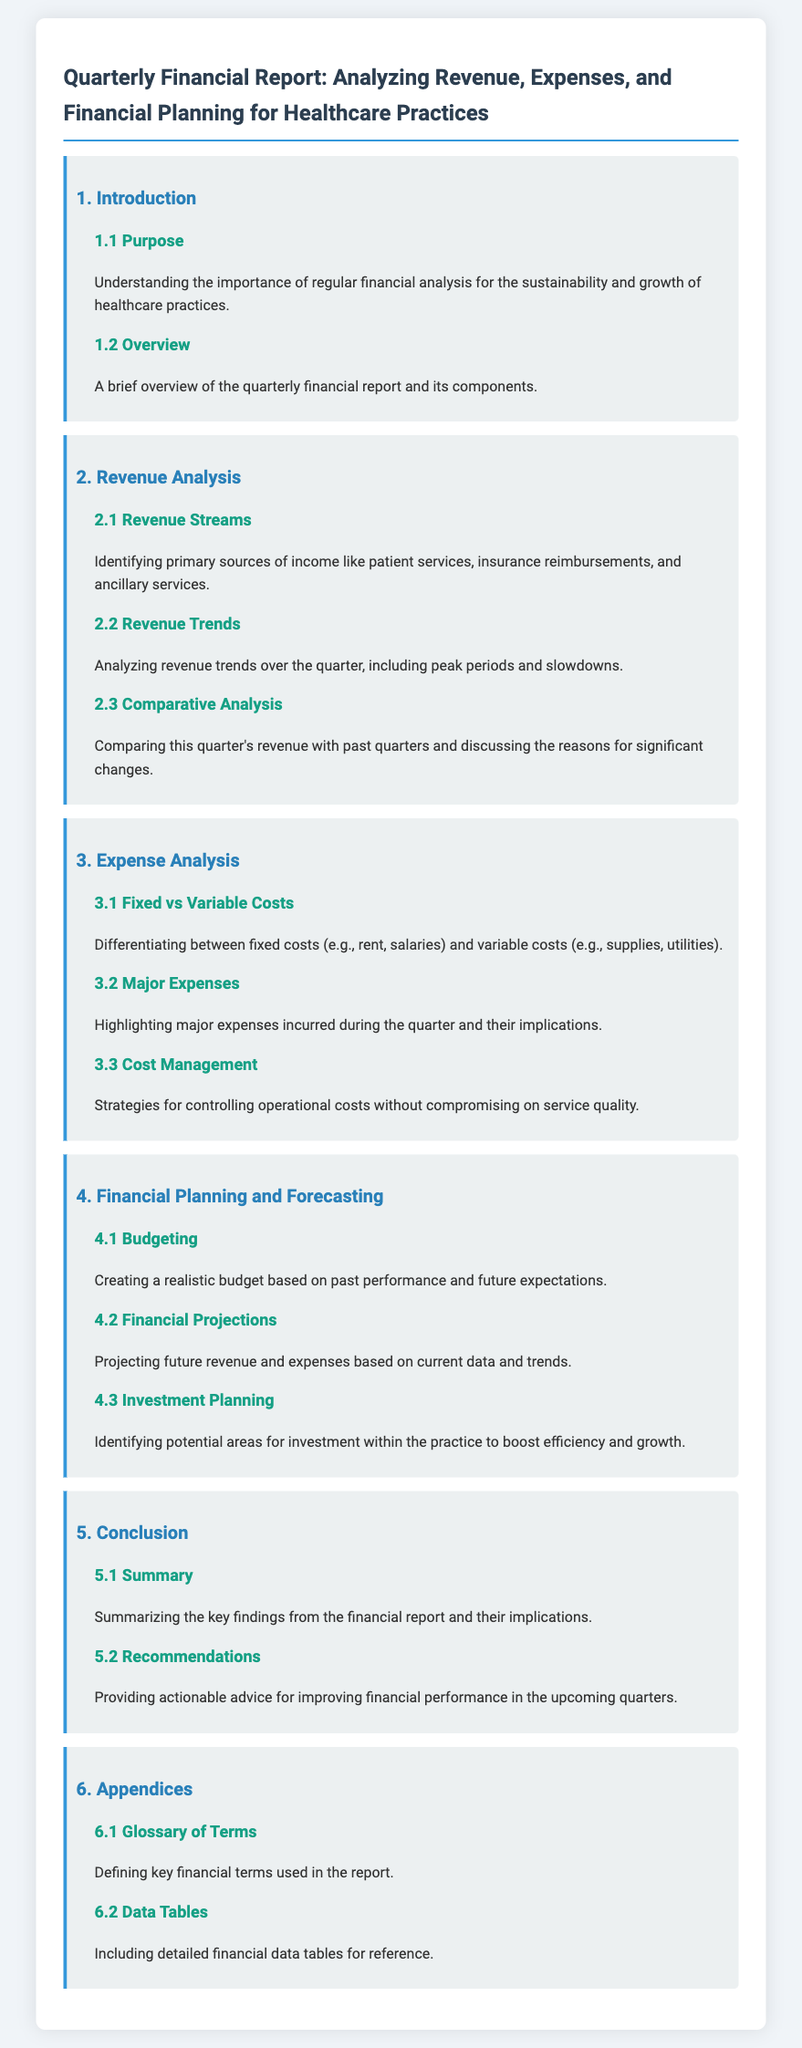What is the purpose of the report? The purpose is to understand the importance of regular financial analysis for the sustainability and growth of healthcare practices.
Answer: Importance of regular financial analysis What section highlights major expenses? The section focusing on major expenses is detailed in the Expense Analysis category, specifically under Major Expenses.
Answer: Major Expenses What are fixed costs? Fixed costs are differentiated as expenditures that remain constant regardless of production output, such as rent and salaries.
Answer: Rent and salaries Which section discusses strategies for controlling costs? The section that discusses strategies for controlling operational costs is titled Cost Management.
Answer: Cost Management What does the report summarize in the conclusion? The conclusion summarizes key findings from the financial report and their implications.
Answer: Key findings and implications How does the report suggest creating a budget? The report suggests creating a realistic budget based on past performance and future expectations in the Budgeting section.
Answer: Realistic budget based on past performance What does the report identify for investment planning? The report identifies potential areas for investment within the practice to boost efficiency and growth in the Investment Planning section.
Answer: Potential areas for investment What is included in the appendices? The appendices include a glossary of terms and detailed financial data tables for reference.
Answer: Glossary of terms and data tables What is analyzed in the Revenue Trends section? The Revenue Trends section analyzes revenue trends over the quarter, including peak periods and slowdowns.
Answer: Revenue trends over the quarter 